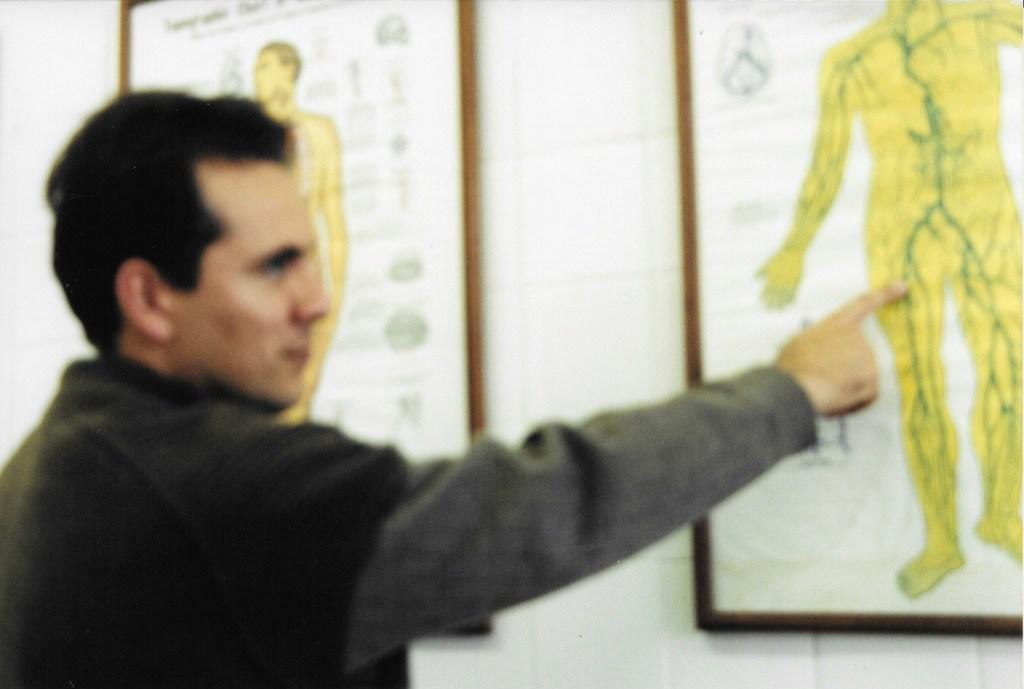Please provide a concise description of this image. In this picture there is a person standing and pointing the board. There are boards on the wall and there are pictures of persons and there is text on the boards. 